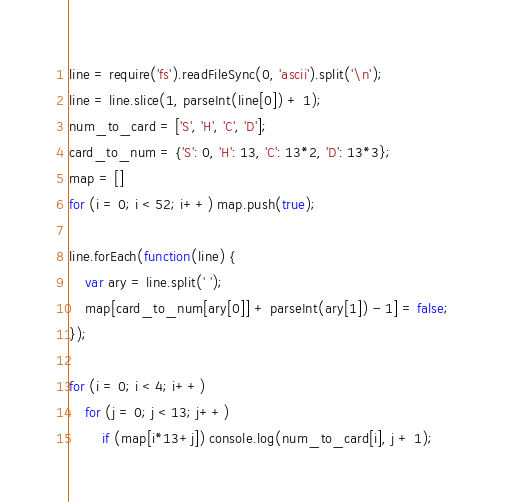<code> <loc_0><loc_0><loc_500><loc_500><_JavaScript_>line = require('fs').readFileSync(0, 'ascii').split('\n');
line = line.slice(1, parseInt(line[0]) + 1);
num_to_card = ['S', 'H', 'C', 'D'];
card_to_num = {'S': 0, 'H': 13, 'C': 13*2, 'D': 13*3};
map = []
for (i = 0; i < 52; i++) map.push(true);

line.forEach(function(line) {
	var ary = line.split(' ');
	map[card_to_num[ary[0]] + parseInt(ary[1]) - 1] = false;
});

for (i = 0; i < 4; i++)
	for (j = 0; j < 13; j++)
		if (map[i*13+j]) console.log(num_to_card[i], j + 1);</code> 